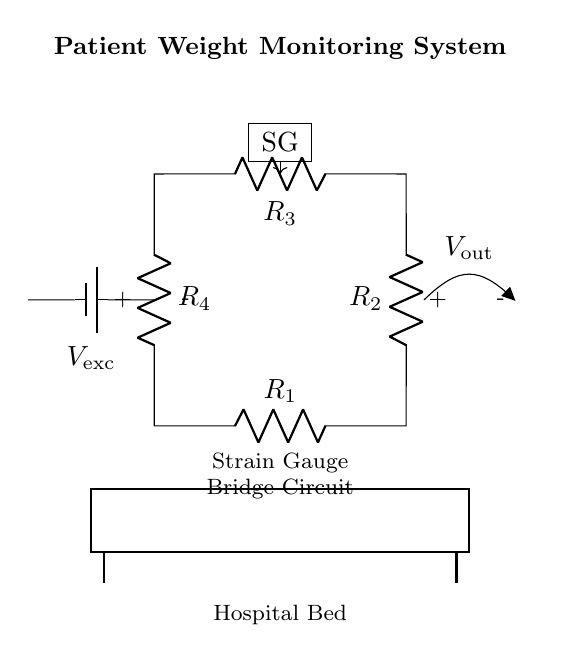What is the type of the circuit shown? The circuit is a bridge circuit, specifically a strain gauge bridge circuit for measuring weight. This is evident from the arrangement of resistors which are configured in a diamond-shaped layout typical of bridge circuits, with a strain gauge component included.
Answer: bridge circuit What is the purpose of the strain gauge in this circuit? The strain gauge measures the deformation caused by weight applied to the hospital bed, and its resistance changes accordingly. This is critical because the change in resistance can be converted to a voltage output representing the weight.
Answer: weight measurement How many resistors are present in the circuit? There are four resistors, denoted as R1, R2, R3, and R4, arranged in a bridge configuration. This is identifiable from the labeled components in the circuit diagram.
Answer: four What is the function of the voltage source in this circuit? The voltage source provides the excitation voltage needed for the bridge circuit to operate; it ensures the resistors have a voltage difference across them, which is necessary for measuring changes in resistance due to the strain gauge deformation.
Answer: excitation voltage What does the output voltage represent in this circuit? The output voltage represents the difference in potential caused by the changes in resistance of the strain gauges in response to weight changes on the bed. This output is critical for monitoring patient weight.
Answer: patient weight difference What component is denoted by SG in the circuit? SG represents the strain gauge, which is the key component for detecting weight variations due to strain from an applied load on the bed. It's an essential part of the weight measuring mechanism in the bridge circuit.
Answer: strain gauge What happens to the output voltage if the bed is empty? If the bed is empty, the strain gauge experiences no deformation, so the output voltage will be zero or very close to zero, indicating no weight. This is because there is no resistance change in the strain gauge, resulting in no voltage difference across the circuit.
Answer: zero 